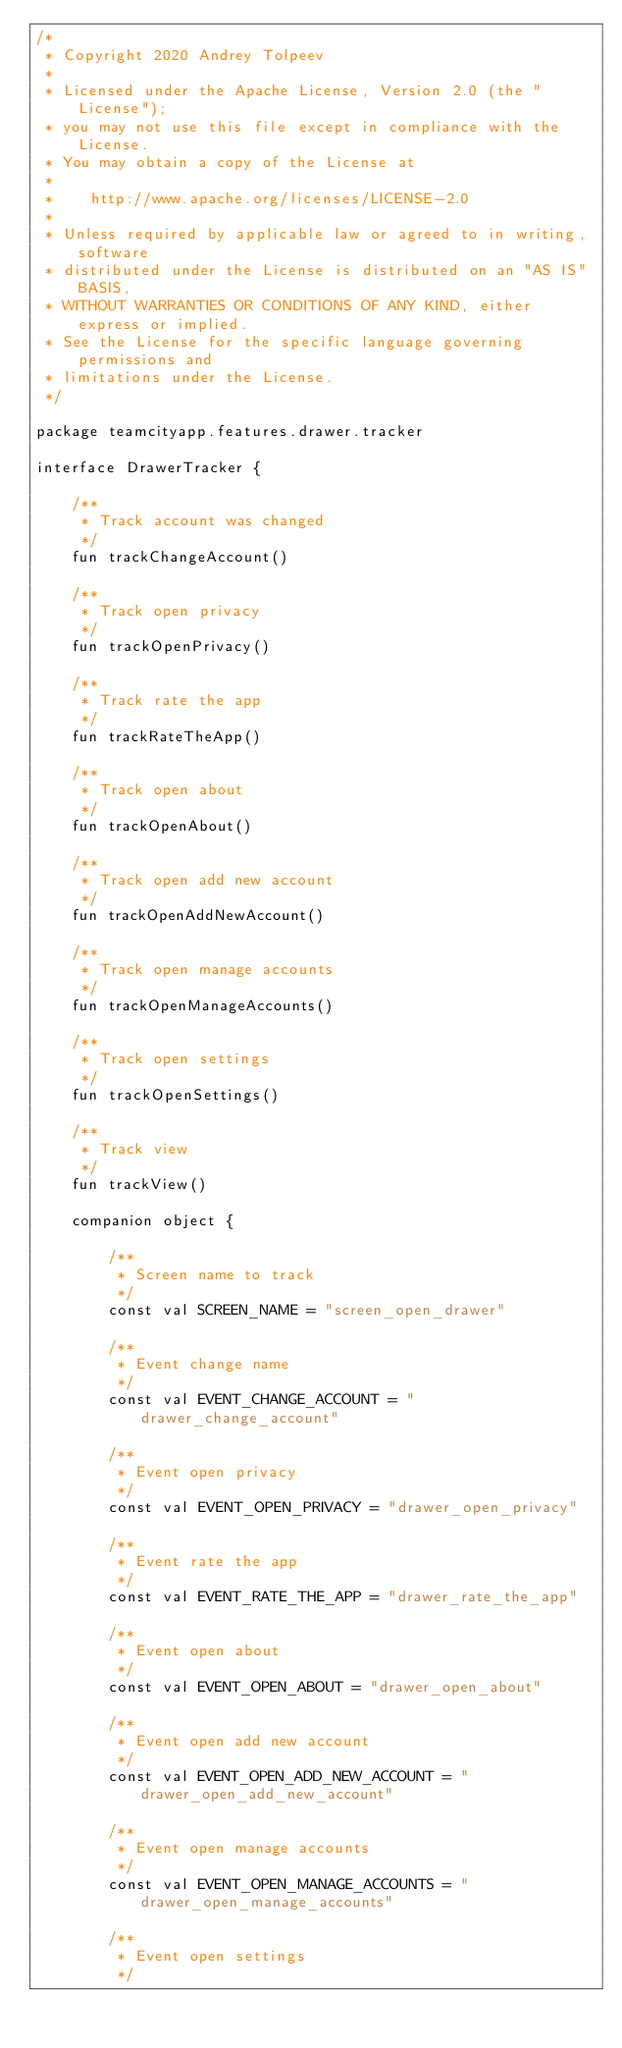Convert code to text. <code><loc_0><loc_0><loc_500><loc_500><_Kotlin_>/*
 * Copyright 2020 Andrey Tolpeev
 *
 * Licensed under the Apache License, Version 2.0 (the "License");
 * you may not use this file except in compliance with the License.
 * You may obtain a copy of the License at
 *
 *    http://www.apache.org/licenses/LICENSE-2.0
 *
 * Unless required by applicable law or agreed to in writing, software
 * distributed under the License is distributed on an "AS IS" BASIS,
 * WITHOUT WARRANTIES OR CONDITIONS OF ANY KIND, either express or implied.
 * See the License for the specific language governing permissions and
 * limitations under the License.
 */

package teamcityapp.features.drawer.tracker

interface DrawerTracker {

    /**
     * Track account was changed
     */
    fun trackChangeAccount()

    /**
     * Track open privacy
     */
    fun trackOpenPrivacy()

    /**
     * Track rate the app
     */
    fun trackRateTheApp()

    /**
     * Track open about
     */
    fun trackOpenAbout()

    /**
     * Track open add new account
     */
    fun trackOpenAddNewAccount()

    /**
     * Track open manage accounts
     */
    fun trackOpenManageAccounts()

    /**
     * Track open settings
     */
    fun trackOpenSettings()

    /**
     * Track view
     */
    fun trackView()

    companion object {

        /**
         * Screen name to track
         */
        const val SCREEN_NAME = "screen_open_drawer"

        /**
         * Event change name
         */
        const val EVENT_CHANGE_ACCOUNT = "drawer_change_account"

        /**
         * Event open privacy
         */
        const val EVENT_OPEN_PRIVACY = "drawer_open_privacy"

        /**
         * Event rate the app
         */
        const val EVENT_RATE_THE_APP = "drawer_rate_the_app"

        /**
         * Event open about
         */
        const val EVENT_OPEN_ABOUT = "drawer_open_about"

        /**
         * Event open add new account
         */
        const val EVENT_OPEN_ADD_NEW_ACCOUNT = "drawer_open_add_new_account"

        /**
         * Event open manage accounts
         */
        const val EVENT_OPEN_MANAGE_ACCOUNTS = "drawer_open_manage_accounts"

        /**
         * Event open settings
         */</code> 